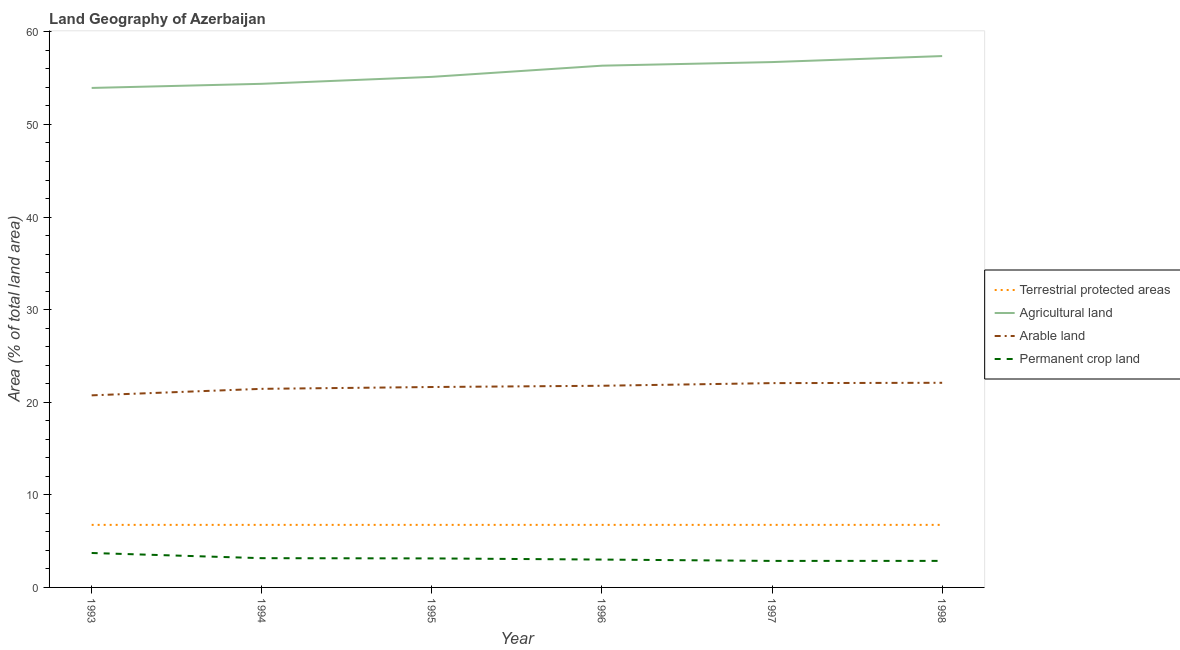How many different coloured lines are there?
Offer a very short reply. 4. Does the line corresponding to percentage of land under terrestrial protection intersect with the line corresponding to percentage of area under arable land?
Your answer should be very brief. No. What is the percentage of area under agricultural land in 1994?
Keep it short and to the point. 54.39. Across all years, what is the maximum percentage of land under terrestrial protection?
Provide a succinct answer. 6.75. Across all years, what is the minimum percentage of area under arable land?
Provide a succinct answer. 20.74. What is the total percentage of area under agricultural land in the graph?
Give a very brief answer. 333.95. What is the difference between the percentage of area under agricultural land in 1993 and that in 1998?
Ensure brevity in your answer.  -3.44. What is the difference between the percentage of area under agricultural land in 1993 and the percentage of land under terrestrial protection in 1996?
Make the answer very short. 47.19. What is the average percentage of area under arable land per year?
Your answer should be compact. 21.63. In the year 1996, what is the difference between the percentage of area under permanent crop land and percentage of area under arable land?
Provide a succinct answer. -18.77. In how many years, is the percentage of land under terrestrial protection greater than 20 %?
Provide a succinct answer. 0. Is the percentage of area under arable land in 1995 less than that in 1997?
Offer a terse response. Yes. Is the difference between the percentage of land under terrestrial protection in 1996 and 1998 greater than the difference between the percentage of area under arable land in 1996 and 1998?
Make the answer very short. Yes. What is the difference between the highest and the second highest percentage of area under agricultural land?
Your answer should be compact. 0.65. What is the difference between the highest and the lowest percentage of area under arable land?
Offer a very short reply. 1.36. Is the sum of the percentage of area under permanent crop land in 1995 and 1998 greater than the maximum percentage of land under terrestrial protection across all years?
Provide a short and direct response. No. Is it the case that in every year, the sum of the percentage of land under terrestrial protection and percentage of area under agricultural land is greater than the percentage of area under arable land?
Ensure brevity in your answer.  Yes. How many lines are there?
Give a very brief answer. 4. What is the difference between two consecutive major ticks on the Y-axis?
Your response must be concise. 10. Does the graph contain any zero values?
Provide a succinct answer. No. How many legend labels are there?
Offer a very short reply. 4. How are the legend labels stacked?
Keep it short and to the point. Vertical. What is the title of the graph?
Give a very brief answer. Land Geography of Azerbaijan. Does "Fourth 20% of population" appear as one of the legend labels in the graph?
Make the answer very short. No. What is the label or title of the Y-axis?
Keep it short and to the point. Area (% of total land area). What is the Area (% of total land area) in Terrestrial protected areas in 1993?
Provide a succinct answer. 6.75. What is the Area (% of total land area) of Agricultural land in 1993?
Provide a short and direct response. 53.94. What is the Area (% of total land area) of Arable land in 1993?
Make the answer very short. 20.74. What is the Area (% of total land area) of Permanent crop land in 1993?
Make the answer very short. 3.72. What is the Area (% of total land area) of Terrestrial protected areas in 1994?
Your answer should be very brief. 6.75. What is the Area (% of total land area) of Agricultural land in 1994?
Your answer should be very brief. 54.39. What is the Area (% of total land area) of Arable land in 1994?
Offer a terse response. 21.45. What is the Area (% of total land area) in Permanent crop land in 1994?
Offer a terse response. 3.16. What is the Area (% of total land area) in Terrestrial protected areas in 1995?
Provide a succinct answer. 6.75. What is the Area (% of total land area) of Agricultural land in 1995?
Make the answer very short. 55.14. What is the Area (% of total land area) in Arable land in 1995?
Provide a succinct answer. 21.64. What is the Area (% of total land area) of Permanent crop land in 1995?
Your answer should be compact. 3.13. What is the Area (% of total land area) of Terrestrial protected areas in 1996?
Your answer should be compact. 6.75. What is the Area (% of total land area) of Agricultural land in 1996?
Make the answer very short. 56.35. What is the Area (% of total land area) of Arable land in 1996?
Your answer should be compact. 21.78. What is the Area (% of total land area) in Permanent crop land in 1996?
Give a very brief answer. 3.01. What is the Area (% of total land area) of Terrestrial protected areas in 1997?
Keep it short and to the point. 6.75. What is the Area (% of total land area) of Agricultural land in 1997?
Give a very brief answer. 56.74. What is the Area (% of total land area) of Arable land in 1997?
Ensure brevity in your answer.  22.07. What is the Area (% of total land area) of Permanent crop land in 1997?
Ensure brevity in your answer.  2.86. What is the Area (% of total land area) of Terrestrial protected areas in 1998?
Give a very brief answer. 6.75. What is the Area (% of total land area) of Agricultural land in 1998?
Make the answer very short. 57.39. What is the Area (% of total land area) of Arable land in 1998?
Offer a terse response. 22.1. What is the Area (% of total land area) in Permanent crop land in 1998?
Provide a short and direct response. 2.87. Across all years, what is the maximum Area (% of total land area) of Terrestrial protected areas?
Keep it short and to the point. 6.75. Across all years, what is the maximum Area (% of total land area) of Agricultural land?
Keep it short and to the point. 57.39. Across all years, what is the maximum Area (% of total land area) in Arable land?
Your answer should be compact. 22.1. Across all years, what is the maximum Area (% of total land area) in Permanent crop land?
Keep it short and to the point. 3.72. Across all years, what is the minimum Area (% of total land area) in Terrestrial protected areas?
Your answer should be very brief. 6.75. Across all years, what is the minimum Area (% of total land area) in Agricultural land?
Provide a succinct answer. 53.94. Across all years, what is the minimum Area (% of total land area) in Arable land?
Provide a succinct answer. 20.74. Across all years, what is the minimum Area (% of total land area) of Permanent crop land?
Provide a short and direct response. 2.86. What is the total Area (% of total land area) of Terrestrial protected areas in the graph?
Your answer should be compact. 40.53. What is the total Area (% of total land area) in Agricultural land in the graph?
Offer a terse response. 333.95. What is the total Area (% of total land area) in Arable land in the graph?
Offer a terse response. 129.78. What is the total Area (% of total land area) in Permanent crop land in the graph?
Your response must be concise. 18.75. What is the difference between the Area (% of total land area) in Agricultural land in 1993 and that in 1994?
Your response must be concise. -0.45. What is the difference between the Area (% of total land area) in Arable land in 1993 and that in 1994?
Offer a terse response. -0.7. What is the difference between the Area (% of total land area) in Permanent crop land in 1993 and that in 1994?
Offer a very short reply. 0.56. What is the difference between the Area (% of total land area) in Terrestrial protected areas in 1993 and that in 1995?
Offer a very short reply. 0. What is the difference between the Area (% of total land area) in Agricultural land in 1993 and that in 1995?
Your response must be concise. -1.2. What is the difference between the Area (% of total land area) in Arable land in 1993 and that in 1995?
Your answer should be compact. -0.9. What is the difference between the Area (% of total land area) of Permanent crop land in 1993 and that in 1995?
Your answer should be compact. 0.59. What is the difference between the Area (% of total land area) in Terrestrial protected areas in 1993 and that in 1996?
Keep it short and to the point. 0. What is the difference between the Area (% of total land area) in Agricultural land in 1993 and that in 1996?
Give a very brief answer. -2.4. What is the difference between the Area (% of total land area) of Arable land in 1993 and that in 1996?
Your response must be concise. -1.03. What is the difference between the Area (% of total land area) of Permanent crop land in 1993 and that in 1996?
Provide a short and direct response. 0.71. What is the difference between the Area (% of total land area) of Agricultural land in 1993 and that in 1997?
Your answer should be compact. -2.79. What is the difference between the Area (% of total land area) of Arable land in 1993 and that in 1997?
Provide a succinct answer. -1.32. What is the difference between the Area (% of total land area) of Permanent crop land in 1993 and that in 1997?
Offer a terse response. 0.85. What is the difference between the Area (% of total land area) in Agricultural land in 1993 and that in 1998?
Offer a terse response. -3.44. What is the difference between the Area (% of total land area) in Arable land in 1993 and that in 1998?
Your answer should be very brief. -1.36. What is the difference between the Area (% of total land area) of Permanent crop land in 1993 and that in 1998?
Make the answer very short. 0.85. What is the difference between the Area (% of total land area) in Agricultural land in 1994 and that in 1995?
Ensure brevity in your answer.  -0.75. What is the difference between the Area (% of total land area) in Arable land in 1994 and that in 1995?
Provide a short and direct response. -0.2. What is the difference between the Area (% of total land area) of Permanent crop land in 1994 and that in 1995?
Offer a very short reply. 0.03. What is the difference between the Area (% of total land area) of Agricultural land in 1994 and that in 1996?
Give a very brief answer. -1.96. What is the difference between the Area (% of total land area) of Arable land in 1994 and that in 1996?
Offer a very short reply. -0.33. What is the difference between the Area (% of total land area) of Permanent crop land in 1994 and that in 1996?
Offer a very short reply. 0.15. What is the difference between the Area (% of total land area) of Agricultural land in 1994 and that in 1997?
Provide a short and direct response. -2.35. What is the difference between the Area (% of total land area) in Arable land in 1994 and that in 1997?
Provide a short and direct response. -0.62. What is the difference between the Area (% of total land area) of Permanent crop land in 1994 and that in 1997?
Your response must be concise. 0.29. What is the difference between the Area (% of total land area) of Terrestrial protected areas in 1994 and that in 1998?
Your response must be concise. 0. What is the difference between the Area (% of total land area) of Agricultural land in 1994 and that in 1998?
Provide a succinct answer. -3. What is the difference between the Area (% of total land area) of Arable land in 1994 and that in 1998?
Provide a short and direct response. -0.65. What is the difference between the Area (% of total land area) in Permanent crop land in 1994 and that in 1998?
Your response must be concise. 0.29. What is the difference between the Area (% of total land area) in Agricultural land in 1995 and that in 1996?
Offer a very short reply. -1.21. What is the difference between the Area (% of total land area) in Arable land in 1995 and that in 1996?
Provide a short and direct response. -0.13. What is the difference between the Area (% of total land area) of Permanent crop land in 1995 and that in 1996?
Provide a short and direct response. 0.13. What is the difference between the Area (% of total land area) of Agricultural land in 1995 and that in 1997?
Ensure brevity in your answer.  -1.6. What is the difference between the Area (% of total land area) in Arable land in 1995 and that in 1997?
Your answer should be very brief. -0.42. What is the difference between the Area (% of total land area) in Permanent crop land in 1995 and that in 1997?
Keep it short and to the point. 0.27. What is the difference between the Area (% of total land area) of Agricultural land in 1995 and that in 1998?
Provide a short and direct response. -2.25. What is the difference between the Area (% of total land area) of Arable land in 1995 and that in 1998?
Your response must be concise. -0.46. What is the difference between the Area (% of total land area) in Permanent crop land in 1995 and that in 1998?
Your answer should be compact. 0.27. What is the difference between the Area (% of total land area) in Agricultural land in 1996 and that in 1997?
Offer a terse response. -0.39. What is the difference between the Area (% of total land area) in Arable land in 1996 and that in 1997?
Your answer should be very brief. -0.29. What is the difference between the Area (% of total land area) in Permanent crop land in 1996 and that in 1997?
Offer a very short reply. 0.14. What is the difference between the Area (% of total land area) in Agricultural land in 1996 and that in 1998?
Make the answer very short. -1.04. What is the difference between the Area (% of total land area) of Arable land in 1996 and that in 1998?
Ensure brevity in your answer.  -0.32. What is the difference between the Area (% of total land area) of Permanent crop land in 1996 and that in 1998?
Give a very brief answer. 0.14. What is the difference between the Area (% of total land area) in Agricultural land in 1997 and that in 1998?
Provide a succinct answer. -0.65. What is the difference between the Area (% of total land area) in Arable land in 1997 and that in 1998?
Keep it short and to the point. -0.04. What is the difference between the Area (% of total land area) of Permanent crop land in 1997 and that in 1998?
Provide a short and direct response. -0. What is the difference between the Area (% of total land area) in Terrestrial protected areas in 1993 and the Area (% of total land area) in Agricultural land in 1994?
Make the answer very short. -47.64. What is the difference between the Area (% of total land area) in Terrestrial protected areas in 1993 and the Area (% of total land area) in Arable land in 1994?
Keep it short and to the point. -14.69. What is the difference between the Area (% of total land area) in Terrestrial protected areas in 1993 and the Area (% of total land area) in Permanent crop land in 1994?
Your answer should be compact. 3.6. What is the difference between the Area (% of total land area) of Agricultural land in 1993 and the Area (% of total land area) of Arable land in 1994?
Offer a terse response. 32.5. What is the difference between the Area (% of total land area) in Agricultural land in 1993 and the Area (% of total land area) in Permanent crop land in 1994?
Your answer should be very brief. 50.79. What is the difference between the Area (% of total land area) in Arable land in 1993 and the Area (% of total land area) in Permanent crop land in 1994?
Provide a short and direct response. 17.59. What is the difference between the Area (% of total land area) of Terrestrial protected areas in 1993 and the Area (% of total land area) of Agricultural land in 1995?
Offer a terse response. -48.39. What is the difference between the Area (% of total land area) in Terrestrial protected areas in 1993 and the Area (% of total land area) in Arable land in 1995?
Offer a very short reply. -14.89. What is the difference between the Area (% of total land area) of Terrestrial protected areas in 1993 and the Area (% of total land area) of Permanent crop land in 1995?
Your response must be concise. 3.62. What is the difference between the Area (% of total land area) of Agricultural land in 1993 and the Area (% of total land area) of Arable land in 1995?
Offer a terse response. 32.3. What is the difference between the Area (% of total land area) of Agricultural land in 1993 and the Area (% of total land area) of Permanent crop land in 1995?
Offer a very short reply. 50.81. What is the difference between the Area (% of total land area) in Arable land in 1993 and the Area (% of total land area) in Permanent crop land in 1995?
Make the answer very short. 17.61. What is the difference between the Area (% of total land area) of Terrestrial protected areas in 1993 and the Area (% of total land area) of Agricultural land in 1996?
Provide a short and direct response. -49.59. What is the difference between the Area (% of total land area) in Terrestrial protected areas in 1993 and the Area (% of total land area) in Arable land in 1996?
Provide a short and direct response. -15.02. What is the difference between the Area (% of total land area) of Terrestrial protected areas in 1993 and the Area (% of total land area) of Permanent crop land in 1996?
Provide a short and direct response. 3.75. What is the difference between the Area (% of total land area) of Agricultural land in 1993 and the Area (% of total land area) of Arable land in 1996?
Provide a succinct answer. 32.16. What is the difference between the Area (% of total land area) of Agricultural land in 1993 and the Area (% of total land area) of Permanent crop land in 1996?
Make the answer very short. 50.94. What is the difference between the Area (% of total land area) in Arable land in 1993 and the Area (% of total land area) in Permanent crop land in 1996?
Make the answer very short. 17.74. What is the difference between the Area (% of total land area) of Terrestrial protected areas in 1993 and the Area (% of total land area) of Agricultural land in 1997?
Ensure brevity in your answer.  -49.98. What is the difference between the Area (% of total land area) of Terrestrial protected areas in 1993 and the Area (% of total land area) of Arable land in 1997?
Provide a short and direct response. -15.31. What is the difference between the Area (% of total land area) in Terrestrial protected areas in 1993 and the Area (% of total land area) in Permanent crop land in 1997?
Offer a terse response. 3.89. What is the difference between the Area (% of total land area) in Agricultural land in 1993 and the Area (% of total land area) in Arable land in 1997?
Provide a succinct answer. 31.88. What is the difference between the Area (% of total land area) of Agricultural land in 1993 and the Area (% of total land area) of Permanent crop land in 1997?
Keep it short and to the point. 51.08. What is the difference between the Area (% of total land area) of Arable land in 1993 and the Area (% of total land area) of Permanent crop land in 1997?
Your answer should be compact. 17.88. What is the difference between the Area (% of total land area) in Terrestrial protected areas in 1993 and the Area (% of total land area) in Agricultural land in 1998?
Keep it short and to the point. -50.63. What is the difference between the Area (% of total land area) of Terrestrial protected areas in 1993 and the Area (% of total land area) of Arable land in 1998?
Provide a succinct answer. -15.35. What is the difference between the Area (% of total land area) in Terrestrial protected areas in 1993 and the Area (% of total land area) in Permanent crop land in 1998?
Ensure brevity in your answer.  3.89. What is the difference between the Area (% of total land area) of Agricultural land in 1993 and the Area (% of total land area) of Arable land in 1998?
Your response must be concise. 31.84. What is the difference between the Area (% of total land area) of Agricultural land in 1993 and the Area (% of total land area) of Permanent crop land in 1998?
Offer a terse response. 51.08. What is the difference between the Area (% of total land area) in Arable land in 1993 and the Area (% of total land area) in Permanent crop land in 1998?
Ensure brevity in your answer.  17.88. What is the difference between the Area (% of total land area) in Terrestrial protected areas in 1994 and the Area (% of total land area) in Agricultural land in 1995?
Provide a succinct answer. -48.39. What is the difference between the Area (% of total land area) in Terrestrial protected areas in 1994 and the Area (% of total land area) in Arable land in 1995?
Keep it short and to the point. -14.89. What is the difference between the Area (% of total land area) of Terrestrial protected areas in 1994 and the Area (% of total land area) of Permanent crop land in 1995?
Provide a succinct answer. 3.62. What is the difference between the Area (% of total land area) in Agricultural land in 1994 and the Area (% of total land area) in Arable land in 1995?
Your answer should be compact. 32.75. What is the difference between the Area (% of total land area) of Agricultural land in 1994 and the Area (% of total land area) of Permanent crop land in 1995?
Your answer should be very brief. 51.26. What is the difference between the Area (% of total land area) in Arable land in 1994 and the Area (% of total land area) in Permanent crop land in 1995?
Your response must be concise. 18.31. What is the difference between the Area (% of total land area) in Terrestrial protected areas in 1994 and the Area (% of total land area) in Agricultural land in 1996?
Offer a terse response. -49.59. What is the difference between the Area (% of total land area) of Terrestrial protected areas in 1994 and the Area (% of total land area) of Arable land in 1996?
Your response must be concise. -15.02. What is the difference between the Area (% of total land area) in Terrestrial protected areas in 1994 and the Area (% of total land area) in Permanent crop land in 1996?
Offer a terse response. 3.75. What is the difference between the Area (% of total land area) in Agricultural land in 1994 and the Area (% of total land area) in Arable land in 1996?
Offer a terse response. 32.61. What is the difference between the Area (% of total land area) in Agricultural land in 1994 and the Area (% of total land area) in Permanent crop land in 1996?
Your response must be concise. 51.38. What is the difference between the Area (% of total land area) in Arable land in 1994 and the Area (% of total land area) in Permanent crop land in 1996?
Offer a terse response. 18.44. What is the difference between the Area (% of total land area) in Terrestrial protected areas in 1994 and the Area (% of total land area) in Agricultural land in 1997?
Your answer should be very brief. -49.98. What is the difference between the Area (% of total land area) of Terrestrial protected areas in 1994 and the Area (% of total land area) of Arable land in 1997?
Your response must be concise. -15.31. What is the difference between the Area (% of total land area) in Terrestrial protected areas in 1994 and the Area (% of total land area) in Permanent crop land in 1997?
Give a very brief answer. 3.89. What is the difference between the Area (% of total land area) of Agricultural land in 1994 and the Area (% of total land area) of Arable land in 1997?
Offer a very short reply. 32.33. What is the difference between the Area (% of total land area) of Agricultural land in 1994 and the Area (% of total land area) of Permanent crop land in 1997?
Your answer should be very brief. 51.53. What is the difference between the Area (% of total land area) of Arable land in 1994 and the Area (% of total land area) of Permanent crop land in 1997?
Provide a succinct answer. 18.58. What is the difference between the Area (% of total land area) in Terrestrial protected areas in 1994 and the Area (% of total land area) in Agricultural land in 1998?
Offer a terse response. -50.63. What is the difference between the Area (% of total land area) in Terrestrial protected areas in 1994 and the Area (% of total land area) in Arable land in 1998?
Provide a succinct answer. -15.35. What is the difference between the Area (% of total land area) of Terrestrial protected areas in 1994 and the Area (% of total land area) of Permanent crop land in 1998?
Keep it short and to the point. 3.89. What is the difference between the Area (% of total land area) in Agricultural land in 1994 and the Area (% of total land area) in Arable land in 1998?
Your answer should be very brief. 32.29. What is the difference between the Area (% of total land area) in Agricultural land in 1994 and the Area (% of total land area) in Permanent crop land in 1998?
Ensure brevity in your answer.  51.52. What is the difference between the Area (% of total land area) of Arable land in 1994 and the Area (% of total land area) of Permanent crop land in 1998?
Ensure brevity in your answer.  18.58. What is the difference between the Area (% of total land area) in Terrestrial protected areas in 1995 and the Area (% of total land area) in Agricultural land in 1996?
Make the answer very short. -49.59. What is the difference between the Area (% of total land area) in Terrestrial protected areas in 1995 and the Area (% of total land area) in Arable land in 1996?
Offer a very short reply. -15.02. What is the difference between the Area (% of total land area) in Terrestrial protected areas in 1995 and the Area (% of total land area) in Permanent crop land in 1996?
Make the answer very short. 3.75. What is the difference between the Area (% of total land area) of Agricultural land in 1995 and the Area (% of total land area) of Arable land in 1996?
Offer a very short reply. 33.36. What is the difference between the Area (% of total land area) of Agricultural land in 1995 and the Area (% of total land area) of Permanent crop land in 1996?
Provide a succinct answer. 52.13. What is the difference between the Area (% of total land area) in Arable land in 1995 and the Area (% of total land area) in Permanent crop land in 1996?
Give a very brief answer. 18.64. What is the difference between the Area (% of total land area) in Terrestrial protected areas in 1995 and the Area (% of total land area) in Agricultural land in 1997?
Offer a very short reply. -49.98. What is the difference between the Area (% of total land area) in Terrestrial protected areas in 1995 and the Area (% of total land area) in Arable land in 1997?
Offer a very short reply. -15.31. What is the difference between the Area (% of total land area) of Terrestrial protected areas in 1995 and the Area (% of total land area) of Permanent crop land in 1997?
Give a very brief answer. 3.89. What is the difference between the Area (% of total land area) in Agricultural land in 1995 and the Area (% of total land area) in Arable land in 1997?
Your answer should be compact. 33.08. What is the difference between the Area (% of total land area) of Agricultural land in 1995 and the Area (% of total land area) of Permanent crop land in 1997?
Provide a short and direct response. 52.28. What is the difference between the Area (% of total land area) in Arable land in 1995 and the Area (% of total land area) in Permanent crop land in 1997?
Provide a succinct answer. 18.78. What is the difference between the Area (% of total land area) in Terrestrial protected areas in 1995 and the Area (% of total land area) in Agricultural land in 1998?
Provide a succinct answer. -50.63. What is the difference between the Area (% of total land area) in Terrestrial protected areas in 1995 and the Area (% of total land area) in Arable land in 1998?
Provide a succinct answer. -15.35. What is the difference between the Area (% of total land area) in Terrestrial protected areas in 1995 and the Area (% of total land area) in Permanent crop land in 1998?
Your answer should be very brief. 3.89. What is the difference between the Area (% of total land area) in Agricultural land in 1995 and the Area (% of total land area) in Arable land in 1998?
Make the answer very short. 33.04. What is the difference between the Area (% of total land area) of Agricultural land in 1995 and the Area (% of total land area) of Permanent crop land in 1998?
Keep it short and to the point. 52.27. What is the difference between the Area (% of total land area) in Arable land in 1995 and the Area (% of total land area) in Permanent crop land in 1998?
Ensure brevity in your answer.  18.78. What is the difference between the Area (% of total land area) in Terrestrial protected areas in 1996 and the Area (% of total land area) in Agricultural land in 1997?
Your response must be concise. -49.98. What is the difference between the Area (% of total land area) of Terrestrial protected areas in 1996 and the Area (% of total land area) of Arable land in 1997?
Your response must be concise. -15.31. What is the difference between the Area (% of total land area) of Terrestrial protected areas in 1996 and the Area (% of total land area) of Permanent crop land in 1997?
Ensure brevity in your answer.  3.89. What is the difference between the Area (% of total land area) of Agricultural land in 1996 and the Area (% of total land area) of Arable land in 1997?
Make the answer very short. 34.28. What is the difference between the Area (% of total land area) of Agricultural land in 1996 and the Area (% of total land area) of Permanent crop land in 1997?
Make the answer very short. 53.48. What is the difference between the Area (% of total land area) in Arable land in 1996 and the Area (% of total land area) in Permanent crop land in 1997?
Ensure brevity in your answer.  18.92. What is the difference between the Area (% of total land area) in Terrestrial protected areas in 1996 and the Area (% of total land area) in Agricultural land in 1998?
Make the answer very short. -50.63. What is the difference between the Area (% of total land area) in Terrestrial protected areas in 1996 and the Area (% of total land area) in Arable land in 1998?
Offer a terse response. -15.35. What is the difference between the Area (% of total land area) in Terrestrial protected areas in 1996 and the Area (% of total land area) in Permanent crop land in 1998?
Your answer should be very brief. 3.89. What is the difference between the Area (% of total land area) of Agricultural land in 1996 and the Area (% of total land area) of Arable land in 1998?
Your answer should be very brief. 34.25. What is the difference between the Area (% of total land area) of Agricultural land in 1996 and the Area (% of total land area) of Permanent crop land in 1998?
Provide a short and direct response. 53.48. What is the difference between the Area (% of total land area) of Arable land in 1996 and the Area (% of total land area) of Permanent crop land in 1998?
Provide a short and direct response. 18.91. What is the difference between the Area (% of total land area) of Terrestrial protected areas in 1997 and the Area (% of total land area) of Agricultural land in 1998?
Your answer should be compact. -50.63. What is the difference between the Area (% of total land area) of Terrestrial protected areas in 1997 and the Area (% of total land area) of Arable land in 1998?
Your answer should be very brief. -15.35. What is the difference between the Area (% of total land area) in Terrestrial protected areas in 1997 and the Area (% of total land area) in Permanent crop land in 1998?
Your answer should be very brief. 3.89. What is the difference between the Area (% of total land area) of Agricultural land in 1997 and the Area (% of total land area) of Arable land in 1998?
Your answer should be compact. 34.64. What is the difference between the Area (% of total land area) in Agricultural land in 1997 and the Area (% of total land area) in Permanent crop land in 1998?
Provide a short and direct response. 53.87. What is the difference between the Area (% of total land area) in Arable land in 1997 and the Area (% of total land area) in Permanent crop land in 1998?
Your answer should be very brief. 19.2. What is the average Area (% of total land area) in Terrestrial protected areas per year?
Keep it short and to the point. 6.75. What is the average Area (% of total land area) of Agricultural land per year?
Your response must be concise. 55.66. What is the average Area (% of total land area) of Arable land per year?
Offer a terse response. 21.63. What is the average Area (% of total land area) in Permanent crop land per year?
Offer a terse response. 3.13. In the year 1993, what is the difference between the Area (% of total land area) in Terrestrial protected areas and Area (% of total land area) in Agricultural land?
Offer a terse response. -47.19. In the year 1993, what is the difference between the Area (% of total land area) in Terrestrial protected areas and Area (% of total land area) in Arable land?
Provide a short and direct response. -13.99. In the year 1993, what is the difference between the Area (% of total land area) of Terrestrial protected areas and Area (% of total land area) of Permanent crop land?
Keep it short and to the point. 3.04. In the year 1993, what is the difference between the Area (% of total land area) of Agricultural land and Area (% of total land area) of Arable land?
Provide a short and direct response. 33.2. In the year 1993, what is the difference between the Area (% of total land area) of Agricultural land and Area (% of total land area) of Permanent crop land?
Provide a succinct answer. 50.23. In the year 1993, what is the difference between the Area (% of total land area) of Arable land and Area (% of total land area) of Permanent crop land?
Keep it short and to the point. 17.03. In the year 1994, what is the difference between the Area (% of total land area) in Terrestrial protected areas and Area (% of total land area) in Agricultural land?
Your answer should be very brief. -47.64. In the year 1994, what is the difference between the Area (% of total land area) of Terrestrial protected areas and Area (% of total land area) of Arable land?
Give a very brief answer. -14.69. In the year 1994, what is the difference between the Area (% of total land area) in Terrestrial protected areas and Area (% of total land area) in Permanent crop land?
Offer a terse response. 3.6. In the year 1994, what is the difference between the Area (% of total land area) in Agricultural land and Area (% of total land area) in Arable land?
Offer a very short reply. 32.94. In the year 1994, what is the difference between the Area (% of total land area) of Agricultural land and Area (% of total land area) of Permanent crop land?
Your answer should be compact. 51.23. In the year 1994, what is the difference between the Area (% of total land area) of Arable land and Area (% of total land area) of Permanent crop land?
Give a very brief answer. 18.29. In the year 1995, what is the difference between the Area (% of total land area) of Terrestrial protected areas and Area (% of total land area) of Agricultural land?
Make the answer very short. -48.39. In the year 1995, what is the difference between the Area (% of total land area) in Terrestrial protected areas and Area (% of total land area) in Arable land?
Ensure brevity in your answer.  -14.89. In the year 1995, what is the difference between the Area (% of total land area) in Terrestrial protected areas and Area (% of total land area) in Permanent crop land?
Provide a succinct answer. 3.62. In the year 1995, what is the difference between the Area (% of total land area) of Agricultural land and Area (% of total land area) of Arable land?
Offer a very short reply. 33.5. In the year 1995, what is the difference between the Area (% of total land area) of Agricultural land and Area (% of total land area) of Permanent crop land?
Ensure brevity in your answer.  52.01. In the year 1995, what is the difference between the Area (% of total land area) of Arable land and Area (% of total land area) of Permanent crop land?
Offer a very short reply. 18.51. In the year 1996, what is the difference between the Area (% of total land area) of Terrestrial protected areas and Area (% of total land area) of Agricultural land?
Your answer should be compact. -49.59. In the year 1996, what is the difference between the Area (% of total land area) in Terrestrial protected areas and Area (% of total land area) in Arable land?
Ensure brevity in your answer.  -15.02. In the year 1996, what is the difference between the Area (% of total land area) of Terrestrial protected areas and Area (% of total land area) of Permanent crop land?
Provide a short and direct response. 3.75. In the year 1996, what is the difference between the Area (% of total land area) of Agricultural land and Area (% of total land area) of Arable land?
Keep it short and to the point. 34.57. In the year 1996, what is the difference between the Area (% of total land area) in Agricultural land and Area (% of total land area) in Permanent crop land?
Provide a succinct answer. 53.34. In the year 1996, what is the difference between the Area (% of total land area) of Arable land and Area (% of total land area) of Permanent crop land?
Offer a terse response. 18.77. In the year 1997, what is the difference between the Area (% of total land area) in Terrestrial protected areas and Area (% of total land area) in Agricultural land?
Your answer should be very brief. -49.98. In the year 1997, what is the difference between the Area (% of total land area) of Terrestrial protected areas and Area (% of total land area) of Arable land?
Your answer should be compact. -15.31. In the year 1997, what is the difference between the Area (% of total land area) of Terrestrial protected areas and Area (% of total land area) of Permanent crop land?
Provide a succinct answer. 3.89. In the year 1997, what is the difference between the Area (% of total land area) of Agricultural land and Area (% of total land area) of Arable land?
Offer a very short reply. 34.67. In the year 1997, what is the difference between the Area (% of total land area) in Agricultural land and Area (% of total land area) in Permanent crop land?
Ensure brevity in your answer.  53.87. In the year 1997, what is the difference between the Area (% of total land area) in Arable land and Area (% of total land area) in Permanent crop land?
Give a very brief answer. 19.2. In the year 1998, what is the difference between the Area (% of total land area) of Terrestrial protected areas and Area (% of total land area) of Agricultural land?
Your answer should be very brief. -50.63. In the year 1998, what is the difference between the Area (% of total land area) of Terrestrial protected areas and Area (% of total land area) of Arable land?
Keep it short and to the point. -15.35. In the year 1998, what is the difference between the Area (% of total land area) in Terrestrial protected areas and Area (% of total land area) in Permanent crop land?
Give a very brief answer. 3.89. In the year 1998, what is the difference between the Area (% of total land area) of Agricultural land and Area (% of total land area) of Arable land?
Ensure brevity in your answer.  35.29. In the year 1998, what is the difference between the Area (% of total land area) in Agricultural land and Area (% of total land area) in Permanent crop land?
Give a very brief answer. 54.52. In the year 1998, what is the difference between the Area (% of total land area) of Arable land and Area (% of total land area) of Permanent crop land?
Offer a very short reply. 19.23. What is the ratio of the Area (% of total land area) in Arable land in 1993 to that in 1994?
Offer a terse response. 0.97. What is the ratio of the Area (% of total land area) in Permanent crop land in 1993 to that in 1994?
Your response must be concise. 1.18. What is the ratio of the Area (% of total land area) in Terrestrial protected areas in 1993 to that in 1995?
Your answer should be compact. 1. What is the ratio of the Area (% of total land area) in Agricultural land in 1993 to that in 1995?
Make the answer very short. 0.98. What is the ratio of the Area (% of total land area) of Arable land in 1993 to that in 1995?
Your response must be concise. 0.96. What is the ratio of the Area (% of total land area) of Permanent crop land in 1993 to that in 1995?
Give a very brief answer. 1.19. What is the ratio of the Area (% of total land area) of Agricultural land in 1993 to that in 1996?
Provide a succinct answer. 0.96. What is the ratio of the Area (% of total land area) in Arable land in 1993 to that in 1996?
Keep it short and to the point. 0.95. What is the ratio of the Area (% of total land area) of Permanent crop land in 1993 to that in 1996?
Your response must be concise. 1.24. What is the ratio of the Area (% of total land area) of Terrestrial protected areas in 1993 to that in 1997?
Offer a very short reply. 1. What is the ratio of the Area (% of total land area) of Agricultural land in 1993 to that in 1997?
Keep it short and to the point. 0.95. What is the ratio of the Area (% of total land area) in Arable land in 1993 to that in 1997?
Give a very brief answer. 0.94. What is the ratio of the Area (% of total land area) of Permanent crop land in 1993 to that in 1997?
Give a very brief answer. 1.3. What is the ratio of the Area (% of total land area) of Agricultural land in 1993 to that in 1998?
Offer a terse response. 0.94. What is the ratio of the Area (% of total land area) of Arable land in 1993 to that in 1998?
Make the answer very short. 0.94. What is the ratio of the Area (% of total land area) in Permanent crop land in 1993 to that in 1998?
Keep it short and to the point. 1.3. What is the ratio of the Area (% of total land area) in Agricultural land in 1994 to that in 1995?
Offer a terse response. 0.99. What is the ratio of the Area (% of total land area) in Arable land in 1994 to that in 1995?
Provide a succinct answer. 0.99. What is the ratio of the Area (% of total land area) in Permanent crop land in 1994 to that in 1995?
Your answer should be compact. 1.01. What is the ratio of the Area (% of total land area) in Agricultural land in 1994 to that in 1996?
Your response must be concise. 0.97. What is the ratio of the Area (% of total land area) of Arable land in 1994 to that in 1996?
Provide a short and direct response. 0.98. What is the ratio of the Area (% of total land area) in Permanent crop land in 1994 to that in 1996?
Give a very brief answer. 1.05. What is the ratio of the Area (% of total land area) of Terrestrial protected areas in 1994 to that in 1997?
Make the answer very short. 1. What is the ratio of the Area (% of total land area) of Agricultural land in 1994 to that in 1997?
Keep it short and to the point. 0.96. What is the ratio of the Area (% of total land area) of Arable land in 1994 to that in 1997?
Offer a terse response. 0.97. What is the ratio of the Area (% of total land area) in Permanent crop land in 1994 to that in 1997?
Offer a terse response. 1.1. What is the ratio of the Area (% of total land area) in Agricultural land in 1994 to that in 1998?
Provide a short and direct response. 0.95. What is the ratio of the Area (% of total land area) of Arable land in 1994 to that in 1998?
Provide a succinct answer. 0.97. What is the ratio of the Area (% of total land area) of Permanent crop land in 1994 to that in 1998?
Your response must be concise. 1.1. What is the ratio of the Area (% of total land area) in Agricultural land in 1995 to that in 1996?
Provide a short and direct response. 0.98. What is the ratio of the Area (% of total land area) of Permanent crop land in 1995 to that in 1996?
Ensure brevity in your answer.  1.04. What is the ratio of the Area (% of total land area) of Agricultural land in 1995 to that in 1997?
Offer a very short reply. 0.97. What is the ratio of the Area (% of total land area) of Arable land in 1995 to that in 1997?
Provide a short and direct response. 0.98. What is the ratio of the Area (% of total land area) in Permanent crop land in 1995 to that in 1997?
Your answer should be very brief. 1.09. What is the ratio of the Area (% of total land area) of Agricultural land in 1995 to that in 1998?
Keep it short and to the point. 0.96. What is the ratio of the Area (% of total land area) in Arable land in 1995 to that in 1998?
Your response must be concise. 0.98. What is the ratio of the Area (% of total land area) of Permanent crop land in 1995 to that in 1998?
Ensure brevity in your answer.  1.09. What is the ratio of the Area (% of total land area) in Agricultural land in 1996 to that in 1997?
Keep it short and to the point. 0.99. What is the ratio of the Area (% of total land area) in Arable land in 1996 to that in 1997?
Your answer should be compact. 0.99. What is the ratio of the Area (% of total land area) in Permanent crop land in 1996 to that in 1997?
Your answer should be compact. 1.05. What is the ratio of the Area (% of total land area) in Agricultural land in 1996 to that in 1998?
Provide a succinct answer. 0.98. What is the ratio of the Area (% of total land area) in Arable land in 1996 to that in 1998?
Make the answer very short. 0.99. What is the ratio of the Area (% of total land area) in Permanent crop land in 1996 to that in 1998?
Keep it short and to the point. 1.05. What is the ratio of the Area (% of total land area) of Terrestrial protected areas in 1997 to that in 1998?
Your answer should be compact. 1. What is the ratio of the Area (% of total land area) of Agricultural land in 1997 to that in 1998?
Your answer should be compact. 0.99. What is the ratio of the Area (% of total land area) of Arable land in 1997 to that in 1998?
Keep it short and to the point. 1. What is the difference between the highest and the second highest Area (% of total land area) of Agricultural land?
Offer a terse response. 0.65. What is the difference between the highest and the second highest Area (% of total land area) in Arable land?
Provide a succinct answer. 0.04. What is the difference between the highest and the second highest Area (% of total land area) of Permanent crop land?
Provide a short and direct response. 0.56. What is the difference between the highest and the lowest Area (% of total land area) in Agricultural land?
Keep it short and to the point. 3.44. What is the difference between the highest and the lowest Area (% of total land area) in Arable land?
Offer a terse response. 1.36. What is the difference between the highest and the lowest Area (% of total land area) in Permanent crop land?
Give a very brief answer. 0.85. 